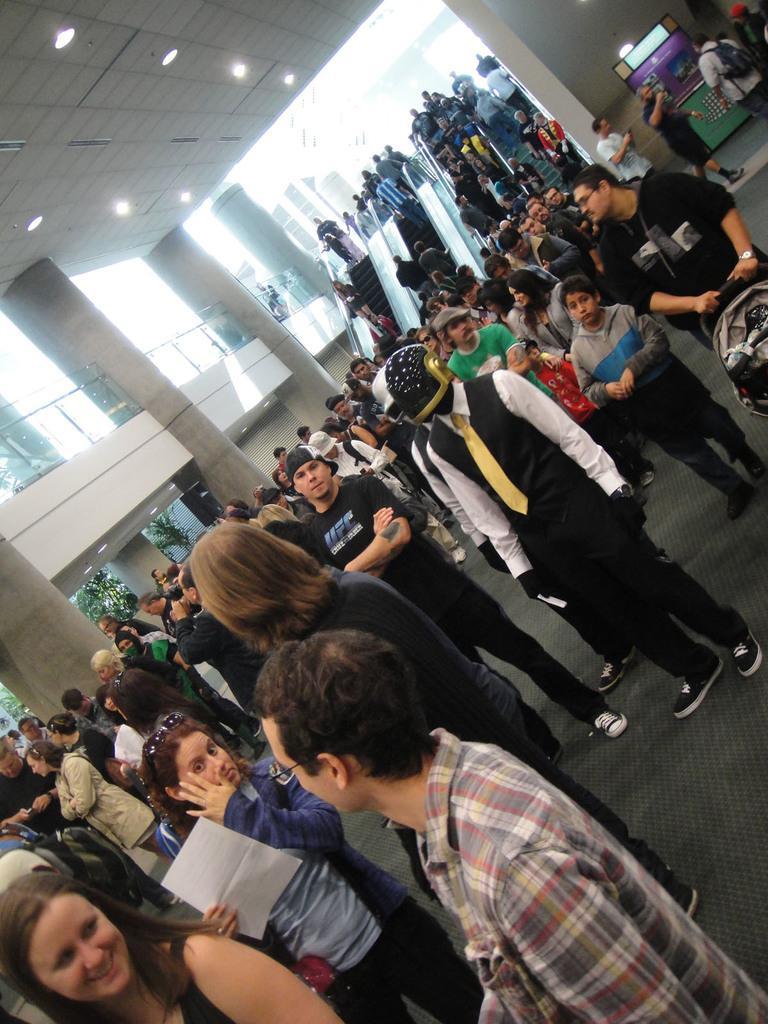In one or two sentences, can you explain what this image depicts? In this image we can see many people, and on the left side we can see some pillar, at the top we can see some ceiling light. 